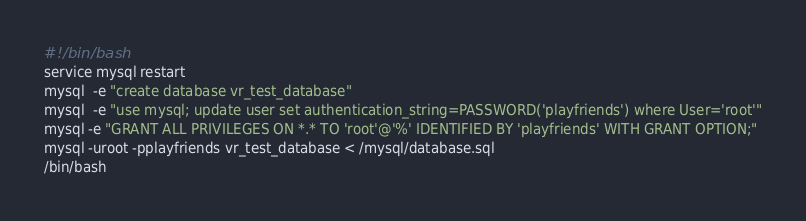Convert code to text. <code><loc_0><loc_0><loc_500><loc_500><_Bash_>#!/bin/bash
service mysql restart
mysql  -e "create database vr_test_database"
mysql  -e "use mysql; update user set authentication_string=PASSWORD('playfriends') where User='root'"
mysql -e "GRANT ALL PRIVILEGES ON *.* TO 'root'@'%' IDENTIFIED BY 'playfriends' WITH GRANT OPTION;"
mysql -uroot -pplayfriends vr_test_database < /mysql/database.sql
/bin/bash</code> 